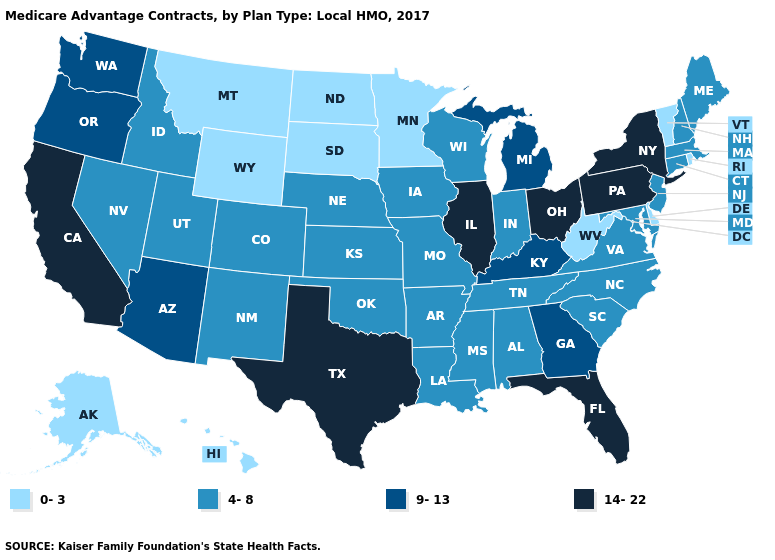Among the states that border North Dakota , which have the highest value?
Keep it brief. Minnesota, Montana, South Dakota. Does Illinois have the highest value in the MidWest?
Concise answer only. Yes. Does Ohio have the highest value in the USA?
Answer briefly. Yes. Does Michigan have the same value as Georgia?
Give a very brief answer. Yes. What is the value of Michigan?
Answer briefly. 9-13. What is the value of Pennsylvania?
Give a very brief answer. 14-22. Name the states that have a value in the range 14-22?
Keep it brief. California, Florida, Illinois, New York, Ohio, Pennsylvania, Texas. Is the legend a continuous bar?
Quick response, please. No. Does the map have missing data?
Concise answer only. No. Name the states that have a value in the range 14-22?
Concise answer only. California, Florida, Illinois, New York, Ohio, Pennsylvania, Texas. Among the states that border Pennsylvania , does New York have the highest value?
Give a very brief answer. Yes. Name the states that have a value in the range 0-3?
Be succinct. Alaska, Delaware, Hawaii, Minnesota, Montana, North Dakota, Rhode Island, South Dakota, Vermont, West Virginia, Wyoming. Which states have the highest value in the USA?
Answer briefly. California, Florida, Illinois, New York, Ohio, Pennsylvania, Texas. Does Alabama have the lowest value in the South?
Short answer required. No. Does Maryland have a lower value than New York?
Quick response, please. Yes. 